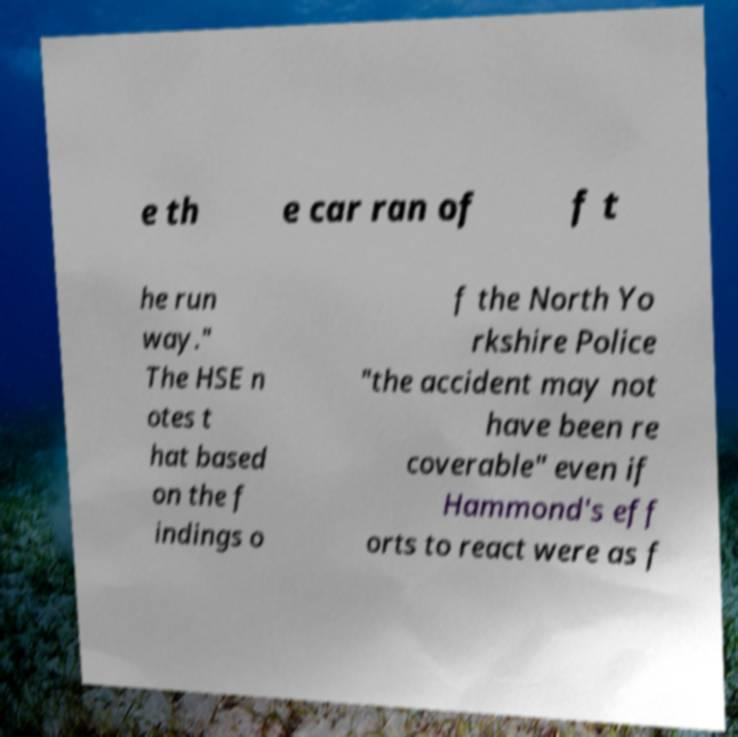Could you assist in decoding the text presented in this image and type it out clearly? e th e car ran of f t he run way." The HSE n otes t hat based on the f indings o f the North Yo rkshire Police "the accident may not have been re coverable" even if Hammond's eff orts to react were as f 